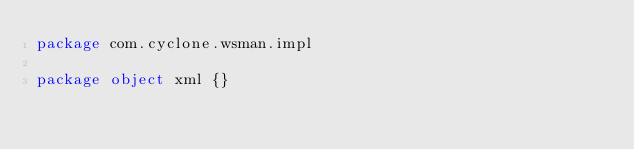<code> <loc_0><loc_0><loc_500><loc_500><_Scala_>package com.cyclone.wsman.impl

package object xml {}
</code> 